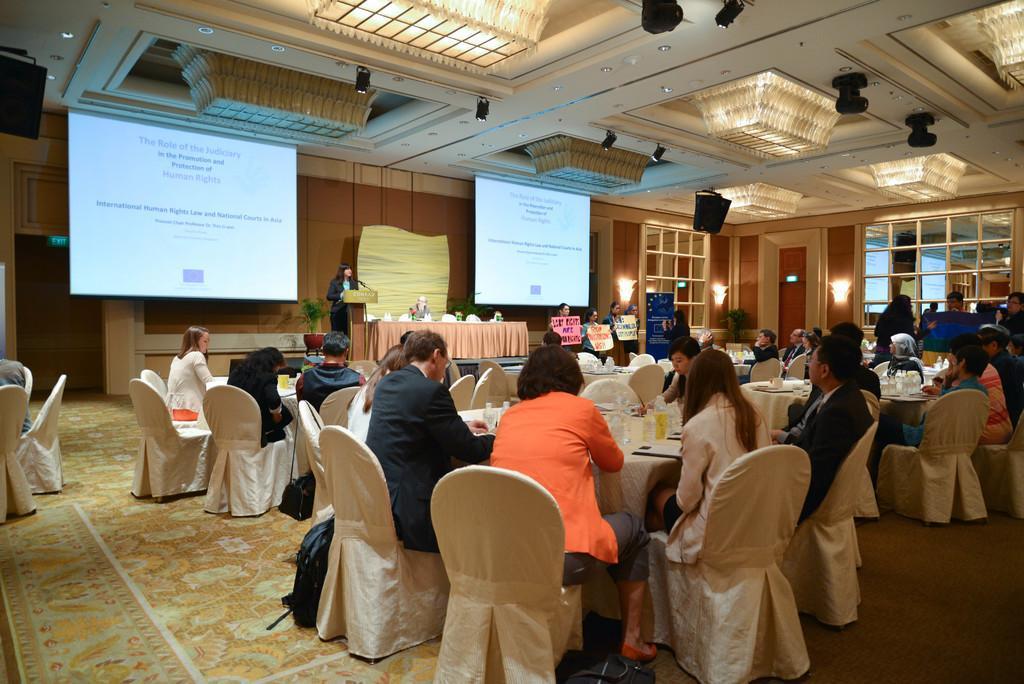How would you summarize this image in a sentence or two? This picture shows a group of people seated on the chairs and we see few bottles on the table and we see a woman Standing and speaking at a podium the help of a microphone and we see projector screens 